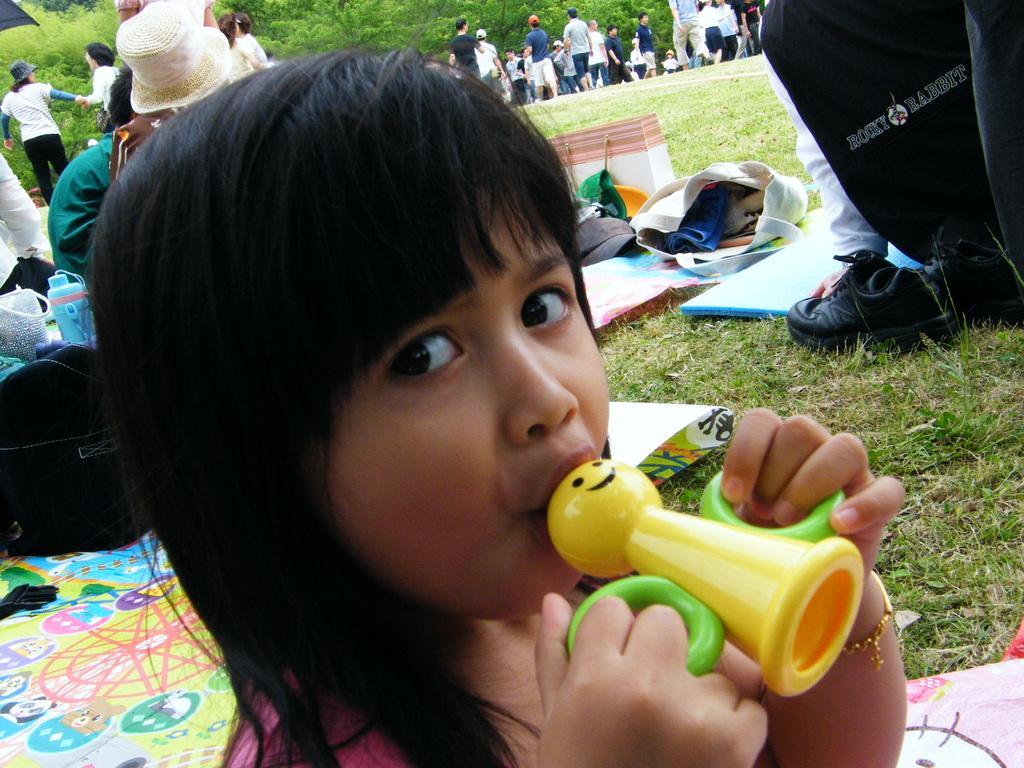How would you summarize this image in a sentence or two? In this image we can see a child holding something in the hand. In the back there's grass on the ground. On the grass we can see mars, shoes, bag, bottle and few other things. Also there are many people. Some are wearing hats. Some are wearing caps. In the background there are trees. 